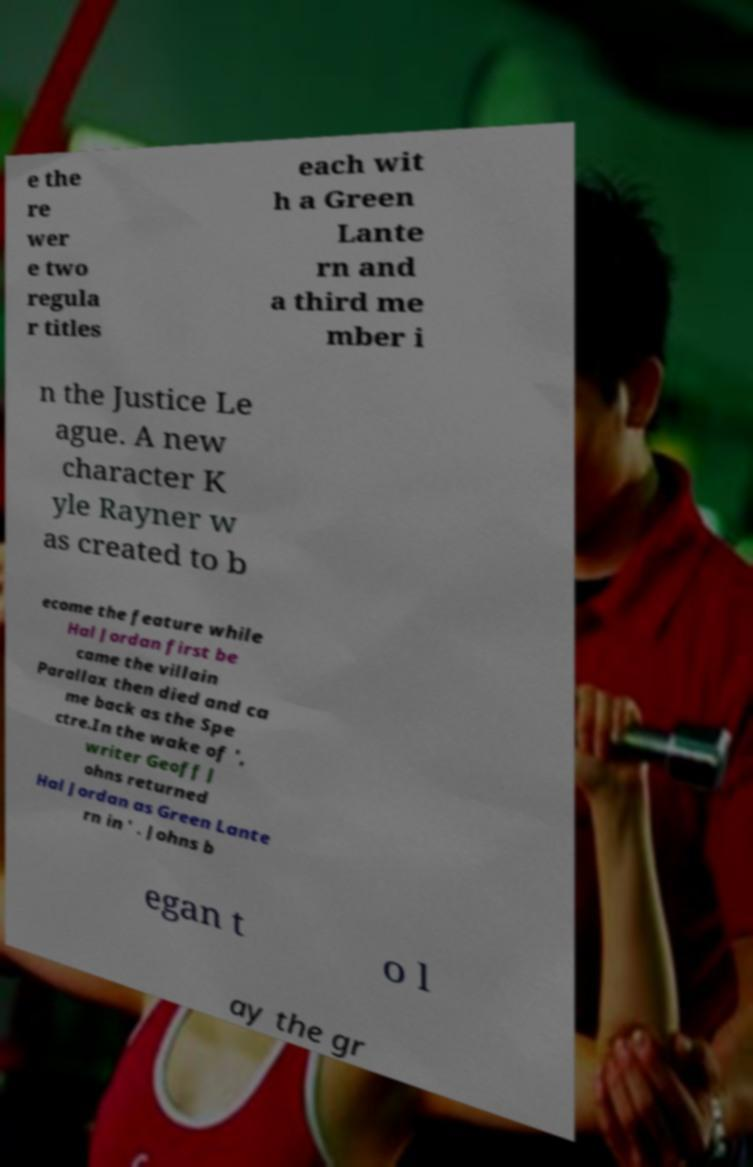For documentation purposes, I need the text within this image transcribed. Could you provide that? e the re wer e two regula r titles each wit h a Green Lante rn and a third me mber i n the Justice Le ague. A new character K yle Rayner w as created to b ecome the feature while Hal Jordan first be came the villain Parallax then died and ca me back as the Spe ctre.In the wake of ', writer Geoff J ohns returned Hal Jordan as Green Lante rn in ' . Johns b egan t o l ay the gr 